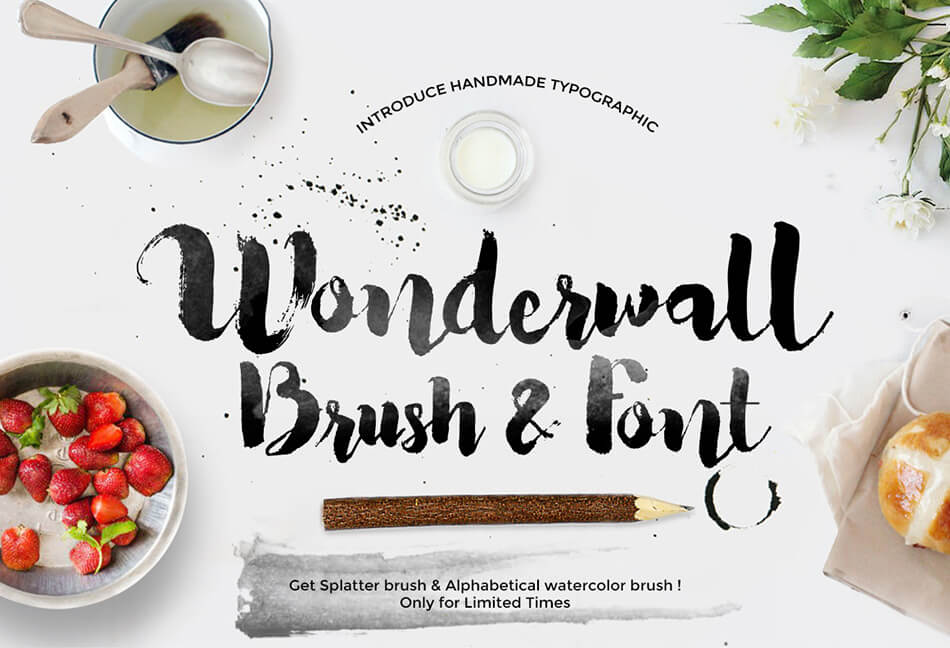Could the choice of items like strawberries and fresh bread signify a deeper thematic connection in the advertisement beyond their visual appeal? Absolutely, the inclusion of strawberries and fresh bread goes beyond mere aesthetics. These items are often associated with freshness and high-quality, natural ingredients, which can subtly underscore the 'Wonderwall' font and brush's suitability for branding and packaging within the food industry, particularly in markets that value organic and artisanal products. This thematic connection suggests that the 'Wonderwall' tools are not just for creating beautiful art, but also for crafting an appealing, authentic narrative around a product that values freshness and quality. 